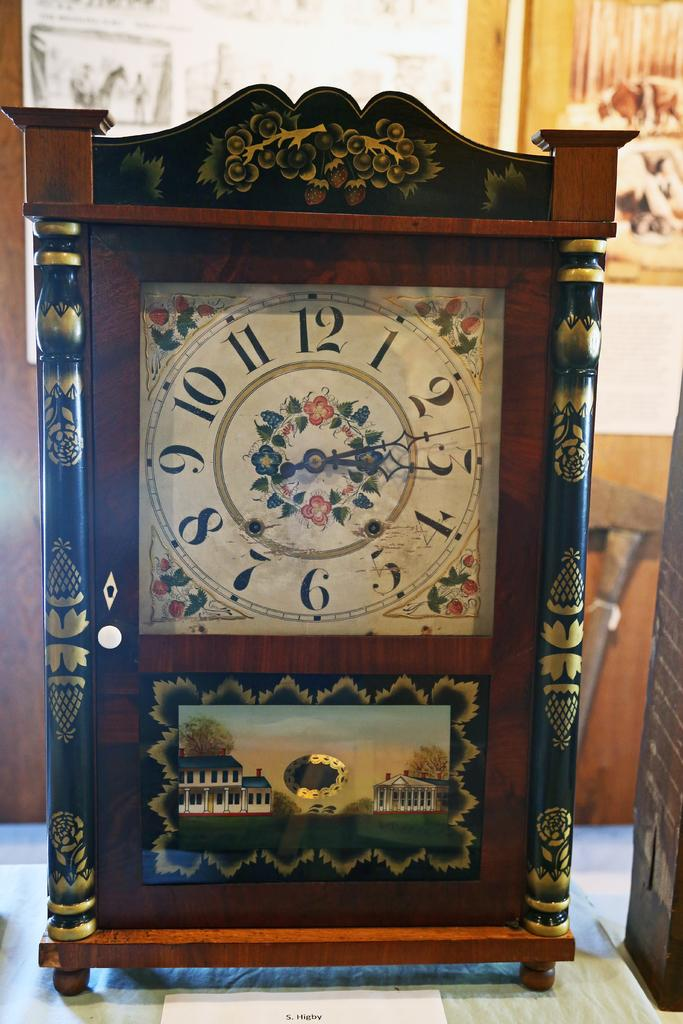<image>
Offer a succinct explanation of the picture presented. An old stand up clock shows a time of 3:13. 